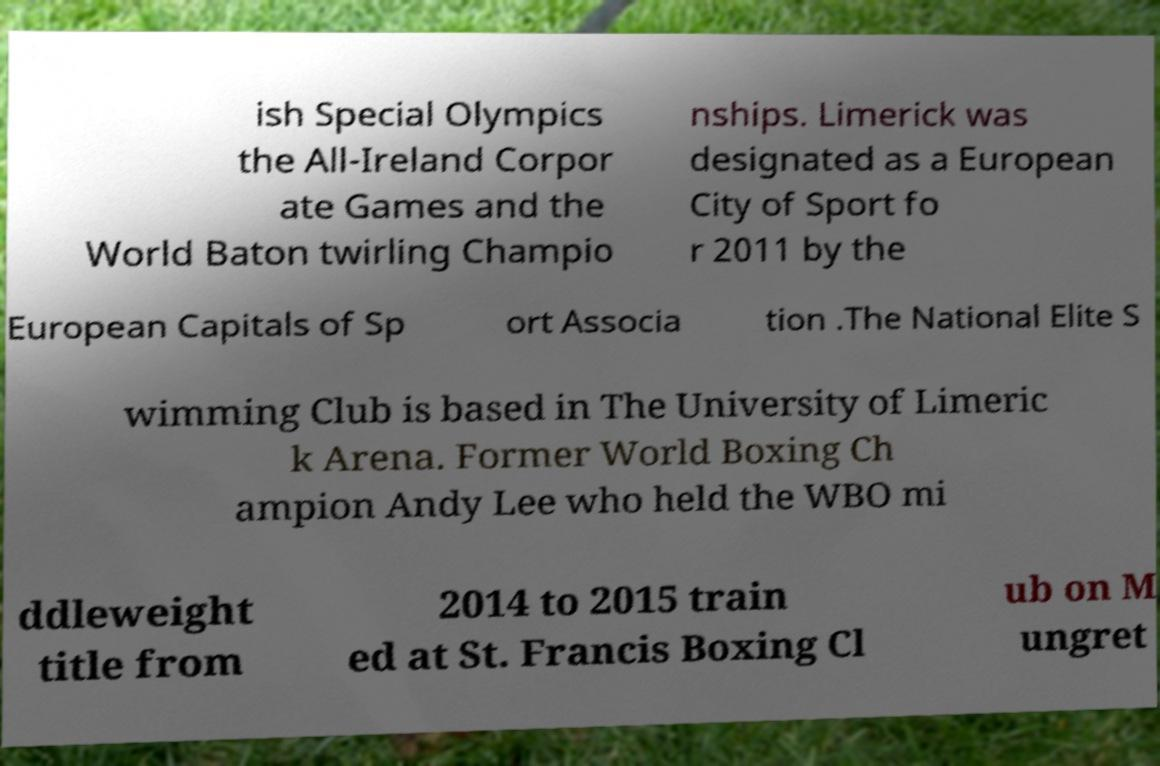Please read and relay the text visible in this image. What does it say? ish Special Olympics the All-Ireland Corpor ate Games and the World Baton twirling Champio nships. Limerick was designated as a European City of Sport fo r 2011 by the European Capitals of Sp ort Associa tion .The National Elite S wimming Club is based in The University of Limeric k Arena. Former World Boxing Ch ampion Andy Lee who held the WBO mi ddleweight title from 2014 to 2015 train ed at St. Francis Boxing Cl ub on M ungret 